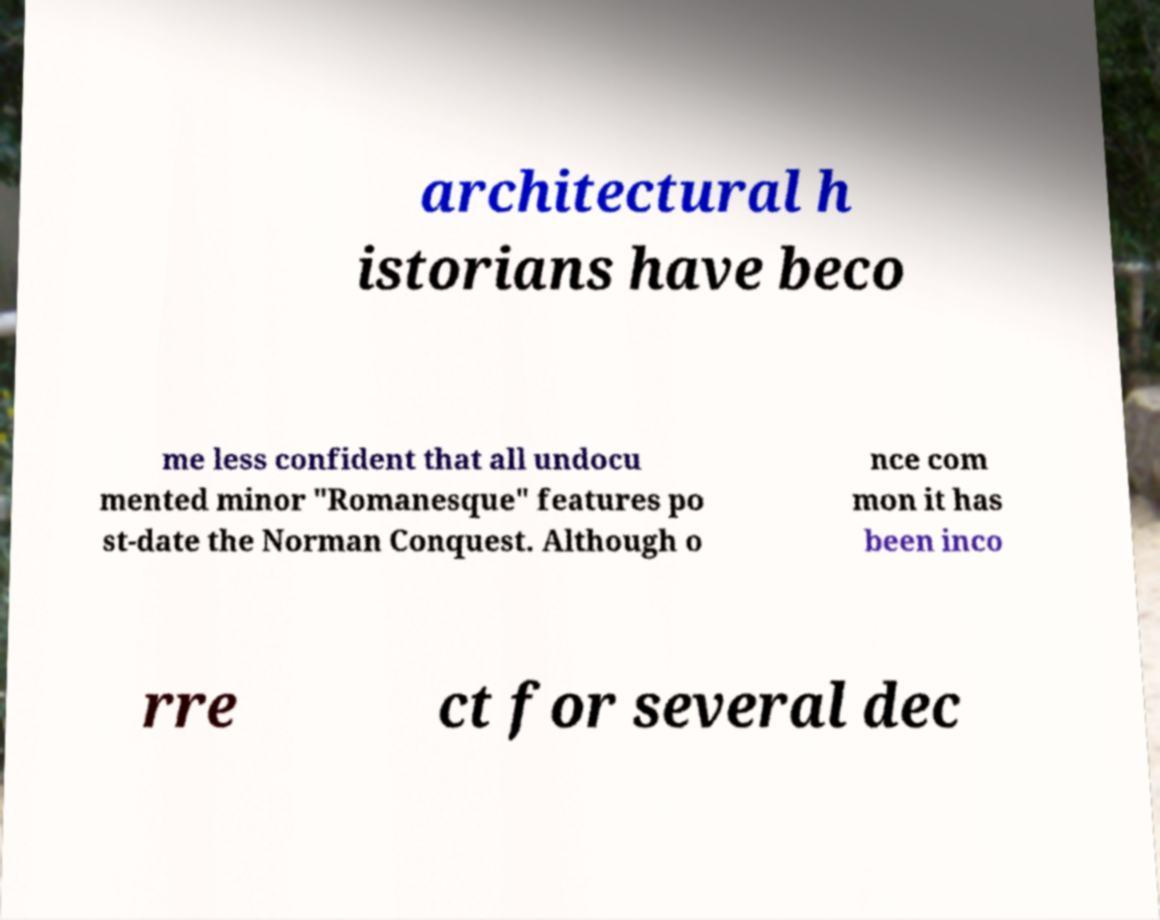I need the written content from this picture converted into text. Can you do that? architectural h istorians have beco me less confident that all undocu mented minor "Romanesque" features po st-date the Norman Conquest. Although o nce com mon it has been inco rre ct for several dec 